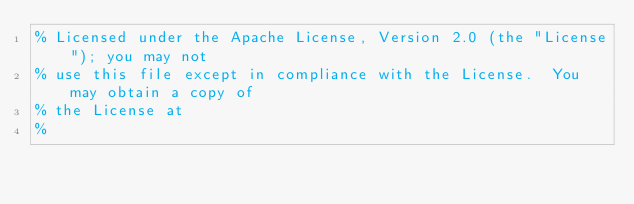<code> <loc_0><loc_0><loc_500><loc_500><_Erlang_>% Licensed under the Apache License, Version 2.0 (the "License"); you may not
% use this file except in compliance with the License.  You may obtain a copy of
% the License at
%</code> 